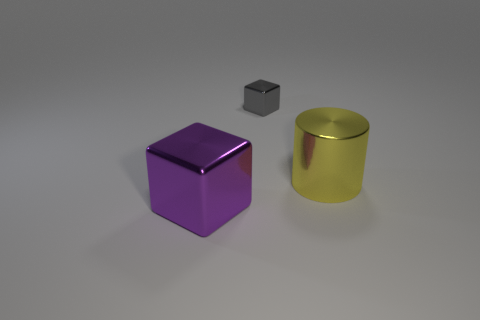Add 2 tiny gray metallic things. How many objects exist? 5 Subtract all cylinders. How many objects are left? 2 Subtract 0 purple cylinders. How many objects are left? 3 Subtract all tiny yellow objects. Subtract all purple blocks. How many objects are left? 2 Add 2 big yellow objects. How many big yellow objects are left? 3 Add 3 small cyan rubber objects. How many small cyan rubber objects exist? 3 